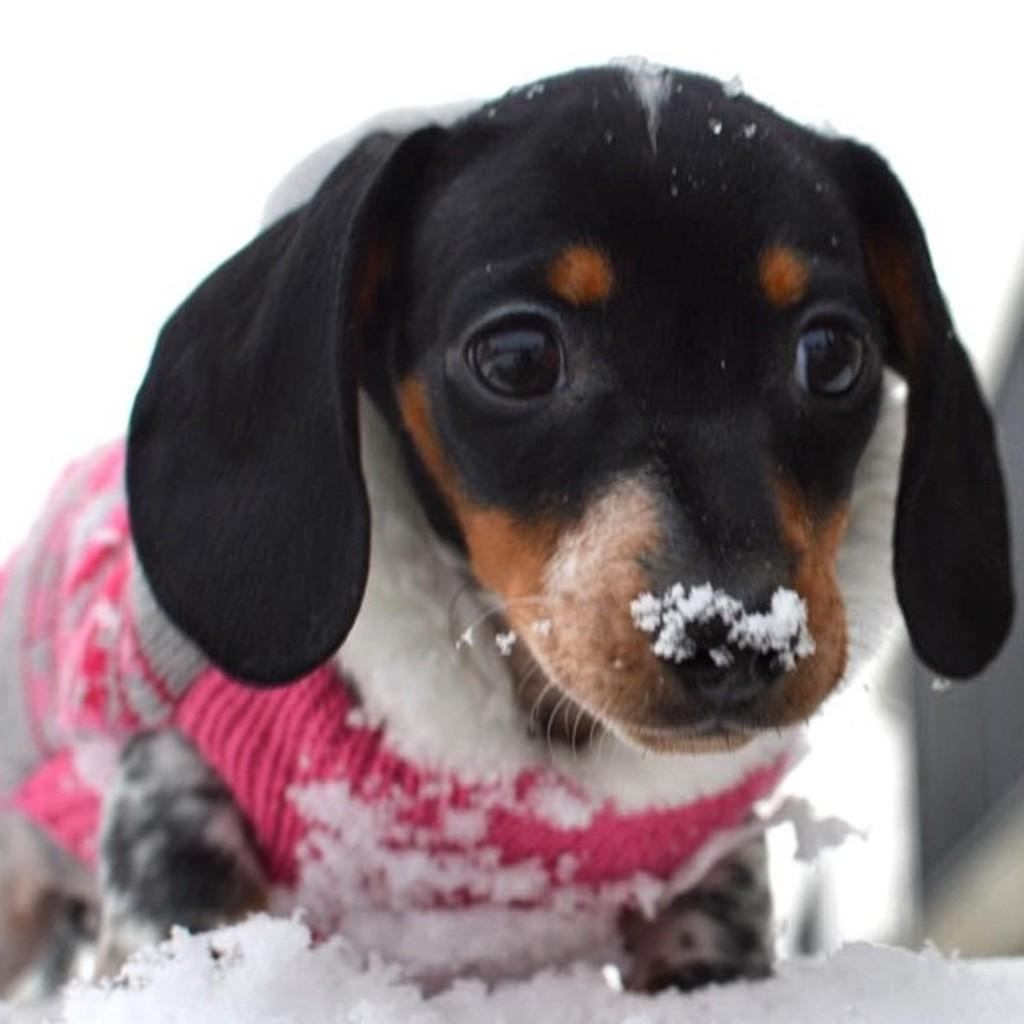What type of animal is in the picture? There is a dog in the picture. What is the dog wearing? The dog is wearing a dress. What is the setting of the picture? There is snow in the picture. How would you describe the background of the image? The background of the image is blurred. What type of plough is being used by the giraffe in the image? There is no giraffe or plough present in the image; it features a dog wearing a dress in a snowy setting with a blurred background. 